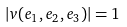<formula> <loc_0><loc_0><loc_500><loc_500>| v ( e _ { 1 } , e _ { 2 } , e _ { 3 } ) | = 1</formula> 